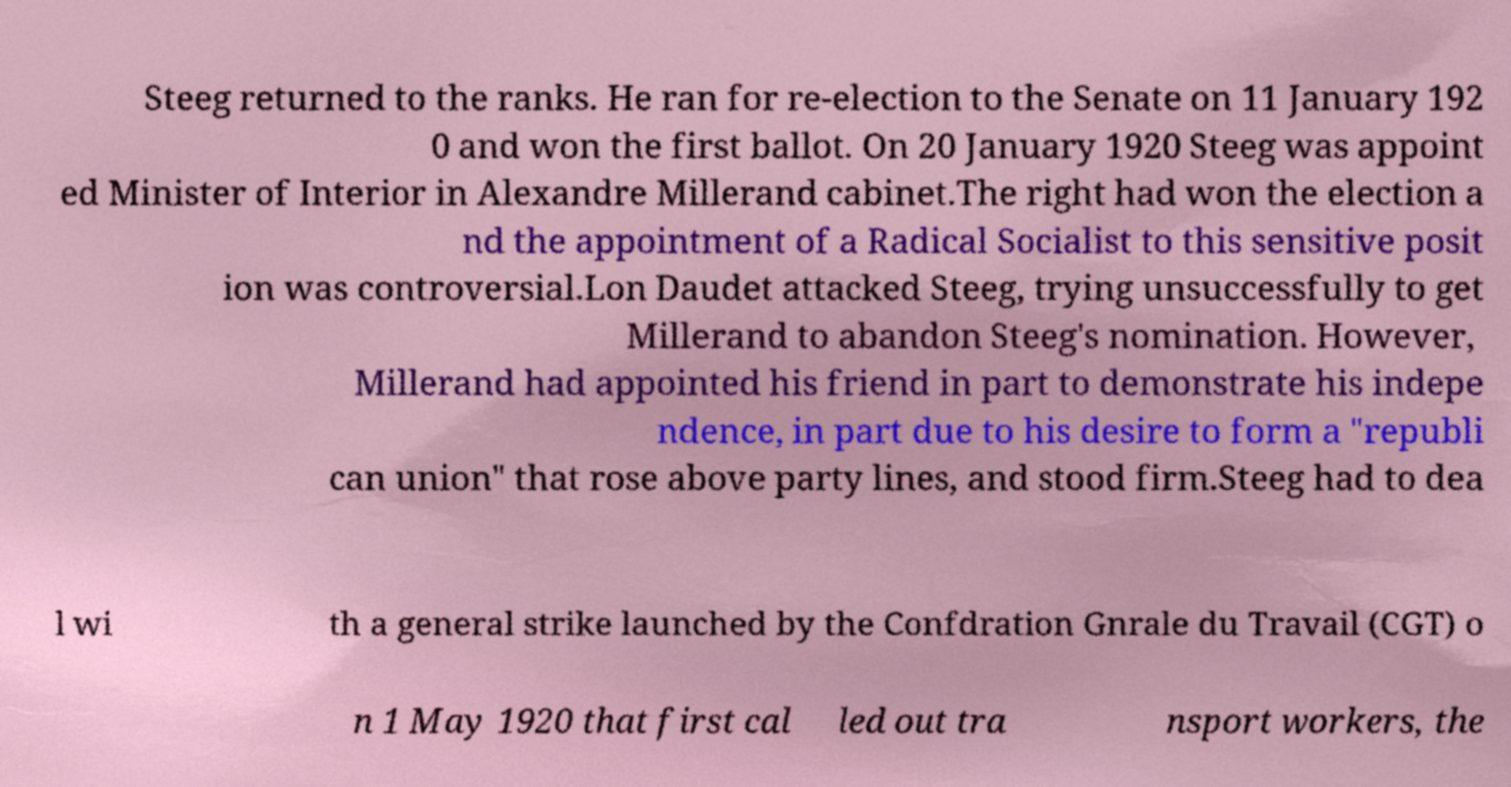For documentation purposes, I need the text within this image transcribed. Could you provide that? Steeg returned to the ranks. He ran for re-election to the Senate on 11 January 192 0 and won the first ballot. On 20 January 1920 Steeg was appoint ed Minister of Interior in Alexandre Millerand cabinet.The right had won the election a nd the appointment of a Radical Socialist to this sensitive posit ion was controversial.Lon Daudet attacked Steeg, trying unsuccessfully to get Millerand to abandon Steeg's nomination. However, Millerand had appointed his friend in part to demonstrate his indepe ndence, in part due to his desire to form a "republi can union" that rose above party lines, and stood firm.Steeg had to dea l wi th a general strike launched by the Confdration Gnrale du Travail (CGT) o n 1 May 1920 that first cal led out tra nsport workers, the 